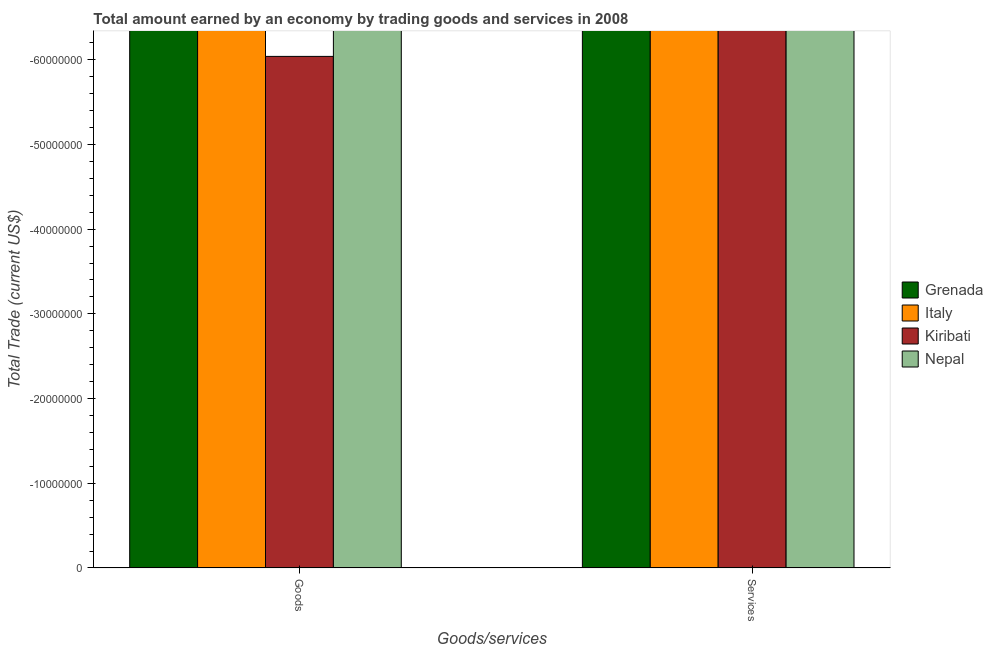How many different coloured bars are there?
Your response must be concise. 0. Are the number of bars per tick equal to the number of legend labels?
Ensure brevity in your answer.  No. How many bars are there on the 2nd tick from the left?
Keep it short and to the point. 0. How many bars are there on the 1st tick from the right?
Your answer should be very brief. 0. What is the label of the 2nd group of bars from the left?
Provide a short and direct response. Services. What is the amount earned by trading services in Italy?
Ensure brevity in your answer.  0. What is the difference between the amount earned by trading goods in Italy and the amount earned by trading services in Kiribati?
Provide a short and direct response. 0. In how many countries, is the amount earned by trading goods greater than -52000000 US$?
Your answer should be very brief. 0. Are all the bars in the graph horizontal?
Your response must be concise. No. What is the difference between two consecutive major ticks on the Y-axis?
Provide a short and direct response. 1.00e+07. How many legend labels are there?
Your answer should be compact. 4. How are the legend labels stacked?
Offer a very short reply. Vertical. What is the title of the graph?
Keep it short and to the point. Total amount earned by an economy by trading goods and services in 2008. What is the label or title of the X-axis?
Keep it short and to the point. Goods/services. What is the label or title of the Y-axis?
Offer a very short reply. Total Trade (current US$). What is the Total Trade (current US$) of Kiribati in Services?
Make the answer very short. 0. What is the average Total Trade (current US$) of Grenada per Goods/services?
Provide a short and direct response. 0. What is the average Total Trade (current US$) of Italy per Goods/services?
Provide a succinct answer. 0. What is the average Total Trade (current US$) in Kiribati per Goods/services?
Your response must be concise. 0. What is the average Total Trade (current US$) of Nepal per Goods/services?
Give a very brief answer. 0. 